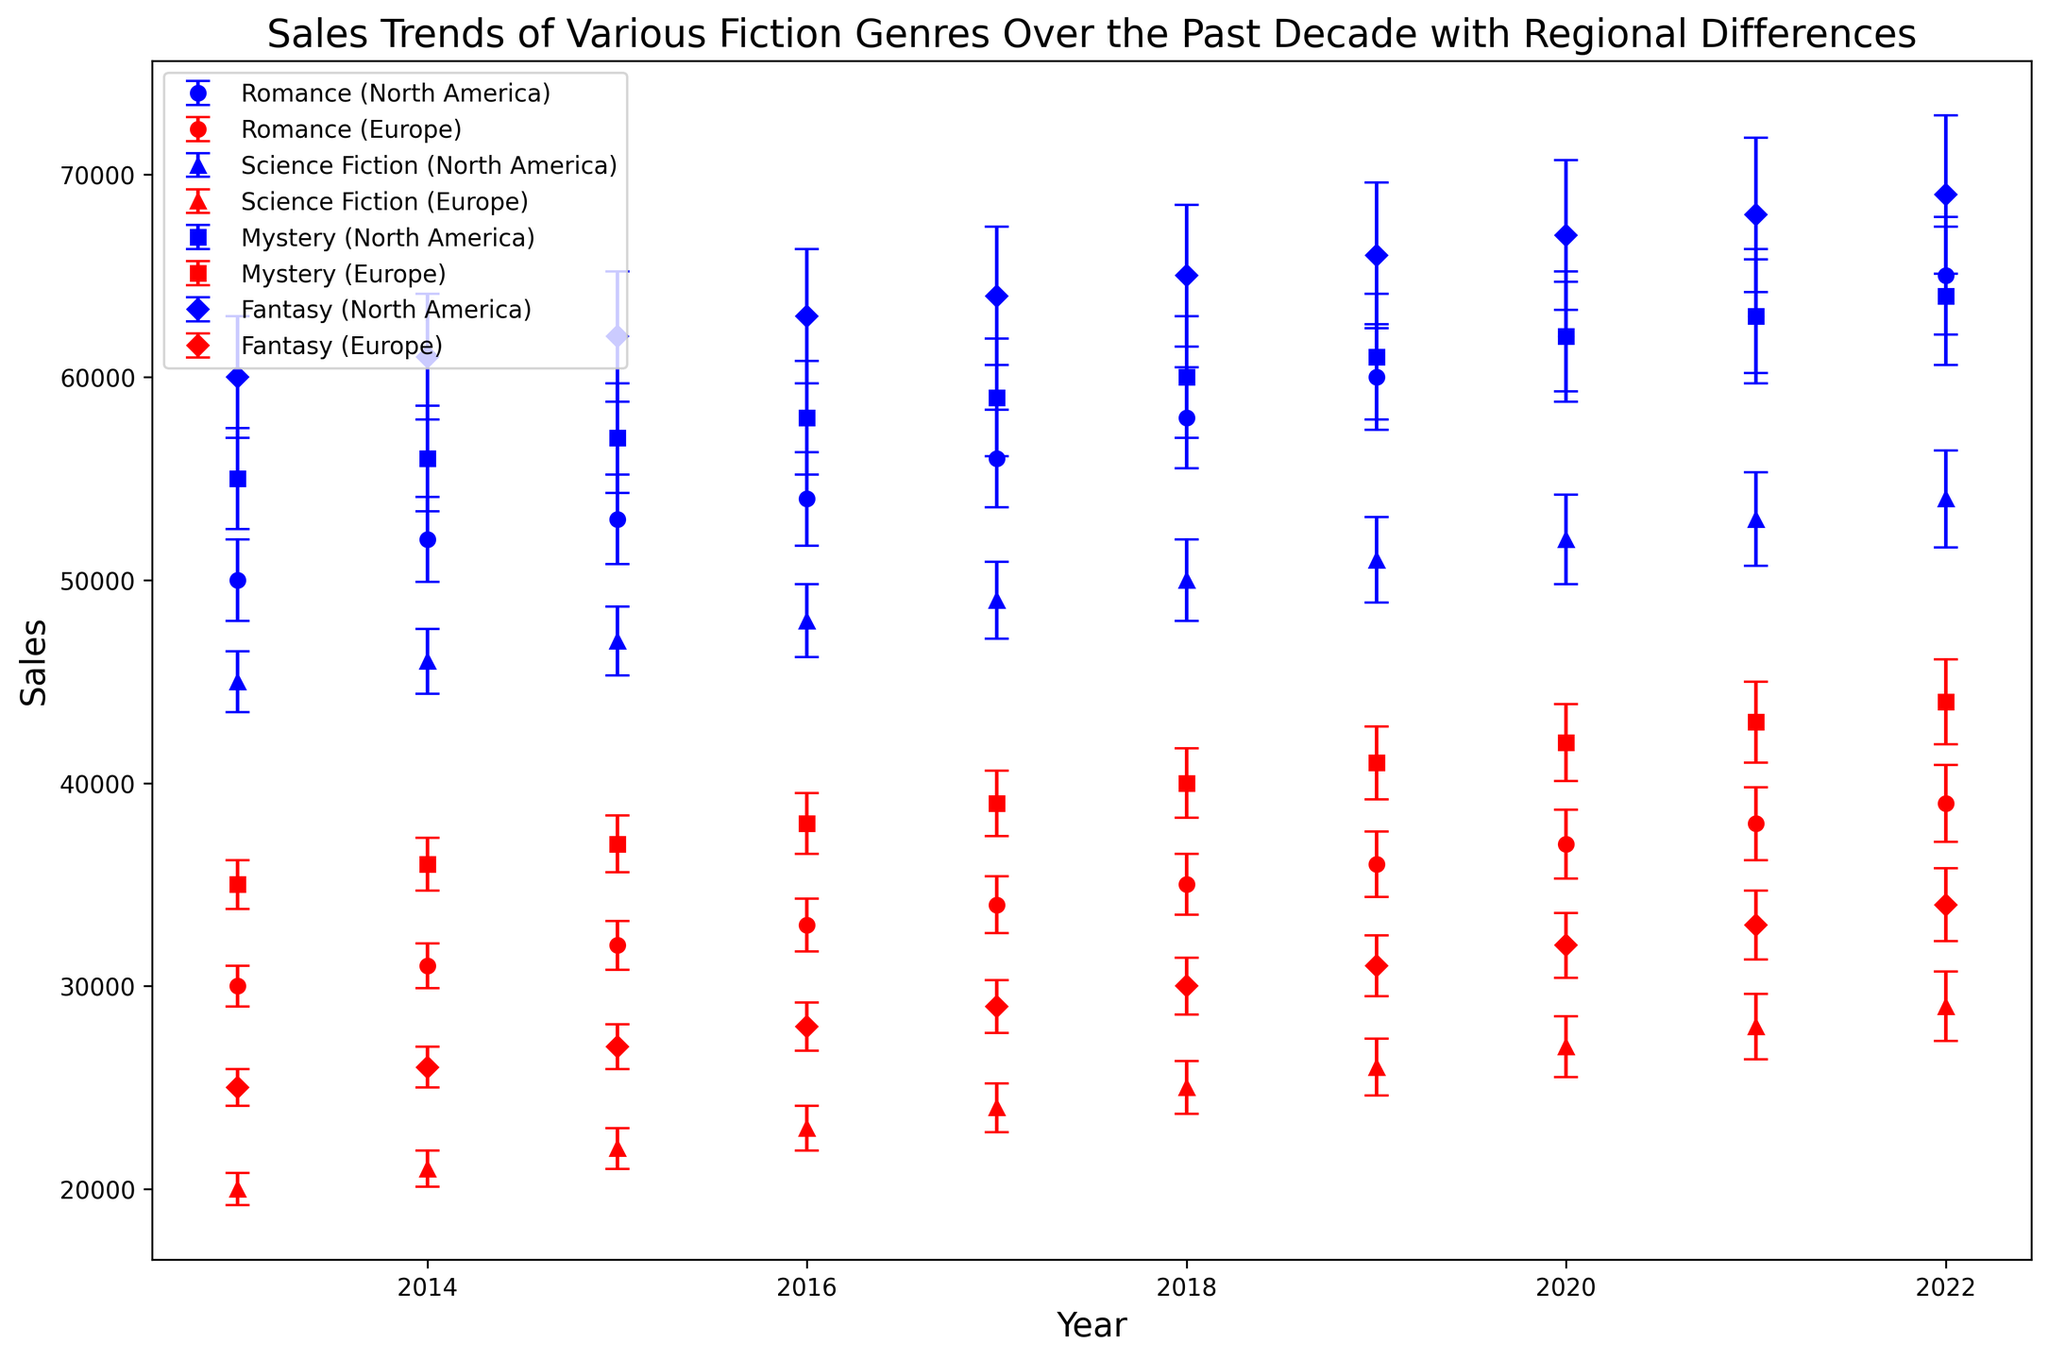Which fiction genre had the highest sales in 2022 in North America? Look at the highest points for each genre in North America in the year 2022. Romance has 65,000, Science Fiction has 54,000, Mystery has 64,000, and Fantasy has 69,000. Fantasy has the highest sales of all.
Answer: Fantasy Which genre shows the largest sales error in North America for 2013? Check the error bars for all genres in North America for the year 2013. The lengths of the error bars are indicators of sales error. Fantasy has an error of 3,000, which is the largest among the genres.
Answer: Fantasy How did the sales trend of Mystery in Europe from 2013 to 2022 compare to that of Science Fiction in the same region and period? Compare the slope of the lines for Mystery and Science Fiction in Europe from 2013 to 2022. Both genres show an increasing trend, but the sales of Mystery increased from 35,000 to 44,000 while Science Fiction increased from 20,000 to 29,000. Thus, Mystery showed a larger absolute increase in sales.
Answer: Mystery In which region did Romance have smaller sales errors overall? Compare the error bar sizes across all years for Romance in both North America and Europe. The error bars for Europe appear consistently shorter, indicating smaller sales errors.
Answer: Europe What are the average sales of Fantasy books in North America from 2013 to 2022? Add the sales of Fantasy books in North America for each year from 2013 (60,000) to 2022 (69,000) and divide by the number of years (10). (60,000 + 61,000 + 62,000 + 63,000 + 64,000 + 65,000 + 66,000 + 67,000 + 68,000 + 69,000) / 10 = 635,000 / 10.
Answer: 63,500 Which genre had the largest increase in sales in North America from 2013 to 2022? Calculate the difference in sales from 2013 to 2022 for each genre in North America. For Romance, it’s 15,000; for Science Fiction, it's 9,000; for Mystery, it's 9,000; and for Fantasy, it’s 9,000. Romance had the largest increase.
Answer: Romance What was the trend of sales for Science Fiction in North America from 2014 to 2017? Observe the points and connect them from 2014 to 2017 for Science Fiction in North America. Each year shows a consistent increase from 46,000 in 2014 to 49,000 in 2017.
Answer: Increasing Which genre in Europe shows the most significant difference in sales compared to the same genre in North America? Compare the sales between Europe and North America for each genre. Science Fiction shows a large difference; in 2013, North America has 45,000 while Europe has 20,000, a difference of 25,000. Other genres have smaller differences.
Answer: Science Fiction How do the sales errors for Mystery in Europe change from 2013 to 2022? Examine the error bars for Mystery in Europe for each year. They increase over time, starting from 1,200 in 2013 to 2,100 in 2022.
Answer: Increasing 